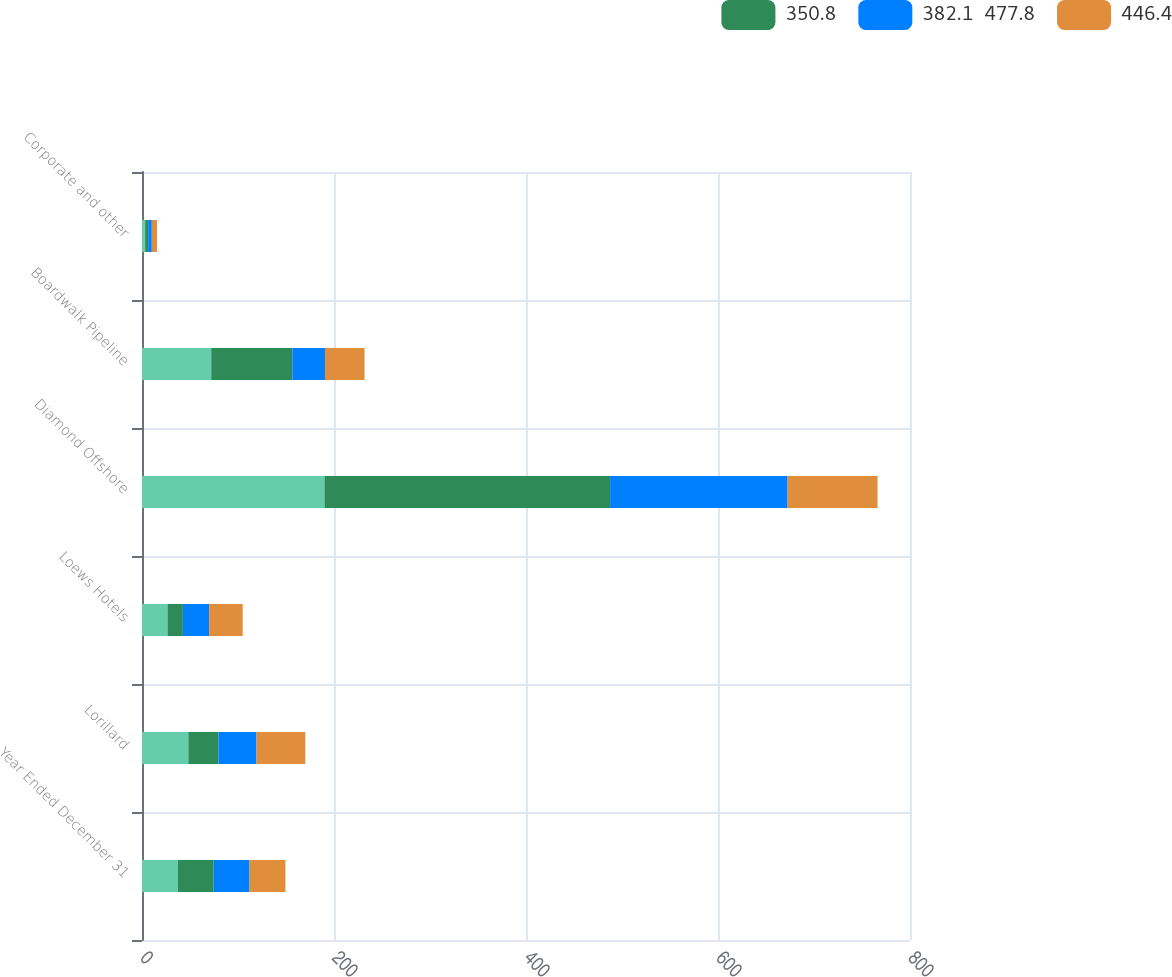Convert chart. <chart><loc_0><loc_0><loc_500><loc_500><stacked_bar_chart><ecel><fcel>Year Ended December 31<fcel>Lorillard<fcel>Loews Hotels<fcel>Diamond Offshore<fcel>Boardwalk Pipeline<fcel>Corporate and other<nl><fcel>nan<fcel>37.35<fcel>48.3<fcel>26.6<fcel>190.1<fcel>72.1<fcel>3.3<nl><fcel>350.8<fcel>37.35<fcel>31.3<fcel>16<fcel>297.5<fcel>84.5<fcel>3.1<nl><fcel>382.1  477.8<fcel>37.35<fcel>39.7<fcel>27.3<fcel>184.9<fcel>34<fcel>3.8<nl><fcel>446.4<fcel>37.35<fcel>50.8<fcel>35<fcel>93.7<fcel>41.2<fcel>5.4<nl></chart> 